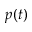<formula> <loc_0><loc_0><loc_500><loc_500>p ( t )</formula> 